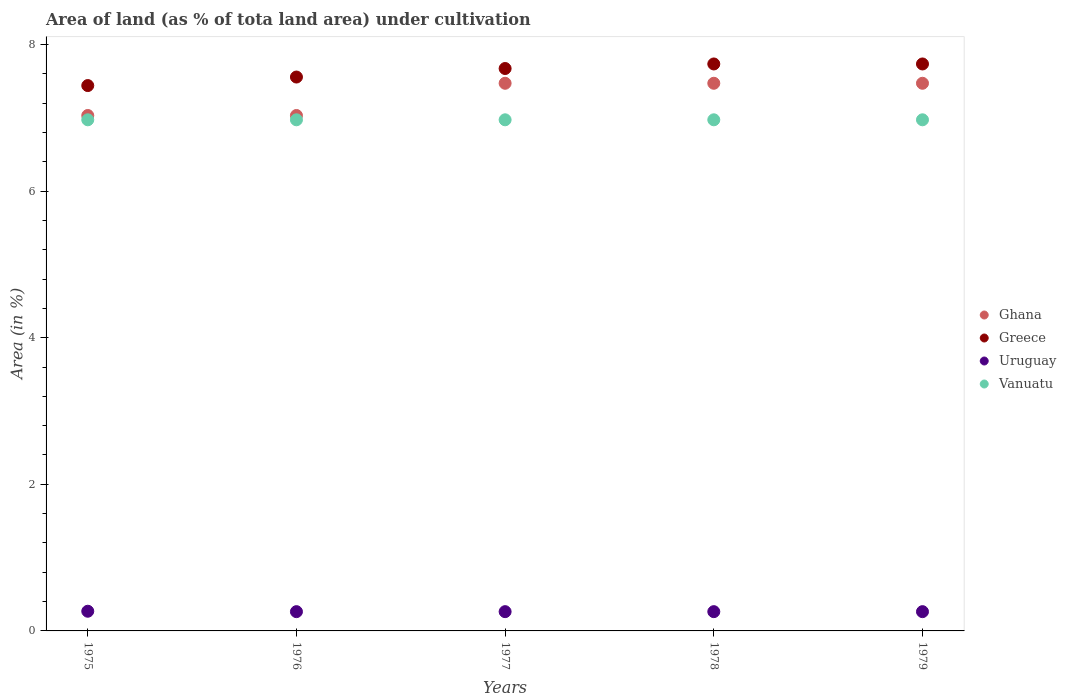What is the percentage of land under cultivation in Ghana in 1976?
Keep it short and to the point. 7.03. Across all years, what is the maximum percentage of land under cultivation in Ghana?
Your answer should be very brief. 7.47. Across all years, what is the minimum percentage of land under cultivation in Greece?
Give a very brief answer. 7.44. In which year was the percentage of land under cultivation in Uruguay maximum?
Provide a short and direct response. 1975. In which year was the percentage of land under cultivation in Ghana minimum?
Keep it short and to the point. 1975. What is the total percentage of land under cultivation in Vanuatu in the graph?
Your answer should be very brief. 34.86. What is the difference between the percentage of land under cultivation in Uruguay in 1978 and that in 1979?
Provide a succinct answer. 0. What is the difference between the percentage of land under cultivation in Greece in 1979 and the percentage of land under cultivation in Uruguay in 1976?
Keep it short and to the point. 7.47. What is the average percentage of land under cultivation in Vanuatu per year?
Provide a short and direct response. 6.97. In the year 1978, what is the difference between the percentage of land under cultivation in Greece and percentage of land under cultivation in Ghana?
Your answer should be compact. 0.26. What is the ratio of the percentage of land under cultivation in Uruguay in 1975 to that in 1977?
Your answer should be very brief. 1.02. Is the percentage of land under cultivation in Vanuatu in 1975 less than that in 1977?
Provide a short and direct response. No. What is the difference between the highest and the second highest percentage of land under cultivation in Uruguay?
Provide a succinct answer. 0.01. Is the sum of the percentage of land under cultivation in Ghana in 1977 and 1979 greater than the maximum percentage of land under cultivation in Uruguay across all years?
Your answer should be compact. Yes. Is it the case that in every year, the sum of the percentage of land under cultivation in Uruguay and percentage of land under cultivation in Ghana  is greater than the percentage of land under cultivation in Greece?
Give a very brief answer. No. How many dotlines are there?
Provide a short and direct response. 4. How many years are there in the graph?
Make the answer very short. 5. What is the title of the graph?
Give a very brief answer. Area of land (as % of tota land area) under cultivation. What is the label or title of the Y-axis?
Offer a very short reply. Area (in %). What is the Area (in %) in Ghana in 1975?
Keep it short and to the point. 7.03. What is the Area (in %) of Greece in 1975?
Keep it short and to the point. 7.44. What is the Area (in %) in Uruguay in 1975?
Give a very brief answer. 0.27. What is the Area (in %) of Vanuatu in 1975?
Give a very brief answer. 6.97. What is the Area (in %) of Ghana in 1976?
Your answer should be compact. 7.03. What is the Area (in %) in Greece in 1976?
Your answer should be very brief. 7.56. What is the Area (in %) of Uruguay in 1976?
Give a very brief answer. 0.26. What is the Area (in %) in Vanuatu in 1976?
Offer a terse response. 6.97. What is the Area (in %) in Ghana in 1977?
Your answer should be compact. 7.47. What is the Area (in %) of Greece in 1977?
Your answer should be compact. 7.67. What is the Area (in %) in Uruguay in 1977?
Make the answer very short. 0.26. What is the Area (in %) in Vanuatu in 1977?
Your response must be concise. 6.97. What is the Area (in %) in Ghana in 1978?
Offer a terse response. 7.47. What is the Area (in %) of Greece in 1978?
Keep it short and to the point. 7.73. What is the Area (in %) of Uruguay in 1978?
Make the answer very short. 0.26. What is the Area (in %) in Vanuatu in 1978?
Your answer should be very brief. 6.97. What is the Area (in %) in Ghana in 1979?
Ensure brevity in your answer.  7.47. What is the Area (in %) of Greece in 1979?
Keep it short and to the point. 7.73. What is the Area (in %) of Uruguay in 1979?
Your answer should be very brief. 0.26. What is the Area (in %) of Vanuatu in 1979?
Provide a short and direct response. 6.97. Across all years, what is the maximum Area (in %) in Ghana?
Your response must be concise. 7.47. Across all years, what is the maximum Area (in %) in Greece?
Provide a succinct answer. 7.73. Across all years, what is the maximum Area (in %) in Uruguay?
Offer a terse response. 0.27. Across all years, what is the maximum Area (in %) in Vanuatu?
Provide a short and direct response. 6.97. Across all years, what is the minimum Area (in %) in Ghana?
Offer a very short reply. 7.03. Across all years, what is the minimum Area (in %) of Greece?
Your answer should be compact. 7.44. Across all years, what is the minimum Area (in %) of Uruguay?
Give a very brief answer. 0.26. Across all years, what is the minimum Area (in %) in Vanuatu?
Ensure brevity in your answer.  6.97. What is the total Area (in %) in Ghana in the graph?
Ensure brevity in your answer.  36.48. What is the total Area (in %) of Greece in the graph?
Make the answer very short. 38.14. What is the total Area (in %) of Uruguay in the graph?
Offer a terse response. 1.32. What is the total Area (in %) in Vanuatu in the graph?
Give a very brief answer. 34.86. What is the difference between the Area (in %) in Ghana in 1975 and that in 1976?
Your answer should be very brief. 0. What is the difference between the Area (in %) in Greece in 1975 and that in 1976?
Offer a terse response. -0.12. What is the difference between the Area (in %) in Uruguay in 1975 and that in 1976?
Your answer should be very brief. 0.01. What is the difference between the Area (in %) in Vanuatu in 1975 and that in 1976?
Your response must be concise. 0. What is the difference between the Area (in %) in Ghana in 1975 and that in 1977?
Your answer should be compact. -0.44. What is the difference between the Area (in %) of Greece in 1975 and that in 1977?
Keep it short and to the point. -0.23. What is the difference between the Area (in %) of Uruguay in 1975 and that in 1977?
Your answer should be very brief. 0.01. What is the difference between the Area (in %) in Ghana in 1975 and that in 1978?
Your response must be concise. -0.44. What is the difference between the Area (in %) in Greece in 1975 and that in 1978?
Provide a short and direct response. -0.29. What is the difference between the Area (in %) in Uruguay in 1975 and that in 1978?
Keep it short and to the point. 0.01. What is the difference between the Area (in %) in Ghana in 1975 and that in 1979?
Make the answer very short. -0.44. What is the difference between the Area (in %) in Greece in 1975 and that in 1979?
Ensure brevity in your answer.  -0.29. What is the difference between the Area (in %) of Uruguay in 1975 and that in 1979?
Provide a short and direct response. 0.01. What is the difference between the Area (in %) in Ghana in 1976 and that in 1977?
Give a very brief answer. -0.44. What is the difference between the Area (in %) in Greece in 1976 and that in 1977?
Ensure brevity in your answer.  -0.12. What is the difference between the Area (in %) in Ghana in 1976 and that in 1978?
Give a very brief answer. -0.44. What is the difference between the Area (in %) in Greece in 1976 and that in 1978?
Your answer should be compact. -0.18. What is the difference between the Area (in %) in Ghana in 1976 and that in 1979?
Offer a terse response. -0.44. What is the difference between the Area (in %) of Greece in 1976 and that in 1979?
Provide a short and direct response. -0.18. What is the difference between the Area (in %) of Uruguay in 1976 and that in 1979?
Ensure brevity in your answer.  0. What is the difference between the Area (in %) of Ghana in 1977 and that in 1978?
Offer a terse response. 0. What is the difference between the Area (in %) of Greece in 1977 and that in 1978?
Offer a very short reply. -0.06. What is the difference between the Area (in %) of Vanuatu in 1977 and that in 1978?
Provide a succinct answer. 0. What is the difference between the Area (in %) in Ghana in 1977 and that in 1979?
Keep it short and to the point. 0. What is the difference between the Area (in %) of Greece in 1977 and that in 1979?
Offer a terse response. -0.06. What is the difference between the Area (in %) in Greece in 1978 and that in 1979?
Offer a very short reply. 0. What is the difference between the Area (in %) of Vanuatu in 1978 and that in 1979?
Provide a succinct answer. 0. What is the difference between the Area (in %) in Ghana in 1975 and the Area (in %) in Greece in 1976?
Your response must be concise. -0.52. What is the difference between the Area (in %) of Ghana in 1975 and the Area (in %) of Uruguay in 1976?
Provide a short and direct response. 6.77. What is the difference between the Area (in %) of Ghana in 1975 and the Area (in %) of Vanuatu in 1976?
Provide a short and direct response. 0.06. What is the difference between the Area (in %) in Greece in 1975 and the Area (in %) in Uruguay in 1976?
Offer a very short reply. 7.18. What is the difference between the Area (in %) in Greece in 1975 and the Area (in %) in Vanuatu in 1976?
Provide a succinct answer. 0.47. What is the difference between the Area (in %) in Uruguay in 1975 and the Area (in %) in Vanuatu in 1976?
Provide a succinct answer. -6.7. What is the difference between the Area (in %) in Ghana in 1975 and the Area (in %) in Greece in 1977?
Provide a short and direct response. -0.64. What is the difference between the Area (in %) of Ghana in 1975 and the Area (in %) of Uruguay in 1977?
Keep it short and to the point. 6.77. What is the difference between the Area (in %) of Ghana in 1975 and the Area (in %) of Vanuatu in 1977?
Offer a terse response. 0.06. What is the difference between the Area (in %) in Greece in 1975 and the Area (in %) in Uruguay in 1977?
Your answer should be very brief. 7.18. What is the difference between the Area (in %) of Greece in 1975 and the Area (in %) of Vanuatu in 1977?
Make the answer very short. 0.47. What is the difference between the Area (in %) in Uruguay in 1975 and the Area (in %) in Vanuatu in 1977?
Make the answer very short. -6.7. What is the difference between the Area (in %) in Ghana in 1975 and the Area (in %) in Greece in 1978?
Your answer should be compact. -0.7. What is the difference between the Area (in %) of Ghana in 1975 and the Area (in %) of Uruguay in 1978?
Your answer should be very brief. 6.77. What is the difference between the Area (in %) in Ghana in 1975 and the Area (in %) in Vanuatu in 1978?
Offer a terse response. 0.06. What is the difference between the Area (in %) in Greece in 1975 and the Area (in %) in Uruguay in 1978?
Provide a succinct answer. 7.18. What is the difference between the Area (in %) of Greece in 1975 and the Area (in %) of Vanuatu in 1978?
Ensure brevity in your answer.  0.47. What is the difference between the Area (in %) of Uruguay in 1975 and the Area (in %) of Vanuatu in 1978?
Keep it short and to the point. -6.7. What is the difference between the Area (in %) in Ghana in 1975 and the Area (in %) in Greece in 1979?
Make the answer very short. -0.7. What is the difference between the Area (in %) of Ghana in 1975 and the Area (in %) of Uruguay in 1979?
Your answer should be compact. 6.77. What is the difference between the Area (in %) in Ghana in 1975 and the Area (in %) in Vanuatu in 1979?
Your answer should be very brief. 0.06. What is the difference between the Area (in %) in Greece in 1975 and the Area (in %) in Uruguay in 1979?
Offer a terse response. 7.18. What is the difference between the Area (in %) in Greece in 1975 and the Area (in %) in Vanuatu in 1979?
Your answer should be compact. 0.47. What is the difference between the Area (in %) of Uruguay in 1975 and the Area (in %) of Vanuatu in 1979?
Your response must be concise. -6.7. What is the difference between the Area (in %) in Ghana in 1976 and the Area (in %) in Greece in 1977?
Offer a terse response. -0.64. What is the difference between the Area (in %) in Ghana in 1976 and the Area (in %) in Uruguay in 1977?
Provide a short and direct response. 6.77. What is the difference between the Area (in %) in Ghana in 1976 and the Area (in %) in Vanuatu in 1977?
Give a very brief answer. 0.06. What is the difference between the Area (in %) in Greece in 1976 and the Area (in %) in Uruguay in 1977?
Your answer should be very brief. 7.29. What is the difference between the Area (in %) of Greece in 1976 and the Area (in %) of Vanuatu in 1977?
Ensure brevity in your answer.  0.58. What is the difference between the Area (in %) in Uruguay in 1976 and the Area (in %) in Vanuatu in 1977?
Give a very brief answer. -6.71. What is the difference between the Area (in %) of Ghana in 1976 and the Area (in %) of Greece in 1978?
Give a very brief answer. -0.7. What is the difference between the Area (in %) of Ghana in 1976 and the Area (in %) of Uruguay in 1978?
Make the answer very short. 6.77. What is the difference between the Area (in %) of Ghana in 1976 and the Area (in %) of Vanuatu in 1978?
Ensure brevity in your answer.  0.06. What is the difference between the Area (in %) of Greece in 1976 and the Area (in %) of Uruguay in 1978?
Provide a succinct answer. 7.29. What is the difference between the Area (in %) of Greece in 1976 and the Area (in %) of Vanuatu in 1978?
Your answer should be very brief. 0.58. What is the difference between the Area (in %) of Uruguay in 1976 and the Area (in %) of Vanuatu in 1978?
Offer a very short reply. -6.71. What is the difference between the Area (in %) in Ghana in 1976 and the Area (in %) in Greece in 1979?
Ensure brevity in your answer.  -0.7. What is the difference between the Area (in %) of Ghana in 1976 and the Area (in %) of Uruguay in 1979?
Make the answer very short. 6.77. What is the difference between the Area (in %) in Ghana in 1976 and the Area (in %) in Vanuatu in 1979?
Offer a very short reply. 0.06. What is the difference between the Area (in %) of Greece in 1976 and the Area (in %) of Uruguay in 1979?
Offer a very short reply. 7.29. What is the difference between the Area (in %) of Greece in 1976 and the Area (in %) of Vanuatu in 1979?
Your answer should be compact. 0.58. What is the difference between the Area (in %) in Uruguay in 1976 and the Area (in %) in Vanuatu in 1979?
Make the answer very short. -6.71. What is the difference between the Area (in %) in Ghana in 1977 and the Area (in %) in Greece in 1978?
Provide a succinct answer. -0.26. What is the difference between the Area (in %) of Ghana in 1977 and the Area (in %) of Uruguay in 1978?
Provide a short and direct response. 7.21. What is the difference between the Area (in %) in Ghana in 1977 and the Area (in %) in Vanuatu in 1978?
Make the answer very short. 0.5. What is the difference between the Area (in %) in Greece in 1977 and the Area (in %) in Uruguay in 1978?
Ensure brevity in your answer.  7.41. What is the difference between the Area (in %) in Greece in 1977 and the Area (in %) in Vanuatu in 1978?
Make the answer very short. 0.7. What is the difference between the Area (in %) of Uruguay in 1977 and the Area (in %) of Vanuatu in 1978?
Make the answer very short. -6.71. What is the difference between the Area (in %) in Ghana in 1977 and the Area (in %) in Greece in 1979?
Give a very brief answer. -0.26. What is the difference between the Area (in %) of Ghana in 1977 and the Area (in %) of Uruguay in 1979?
Your answer should be compact. 7.21. What is the difference between the Area (in %) of Ghana in 1977 and the Area (in %) of Vanuatu in 1979?
Keep it short and to the point. 0.5. What is the difference between the Area (in %) of Greece in 1977 and the Area (in %) of Uruguay in 1979?
Your response must be concise. 7.41. What is the difference between the Area (in %) in Greece in 1977 and the Area (in %) in Vanuatu in 1979?
Your answer should be very brief. 0.7. What is the difference between the Area (in %) in Uruguay in 1977 and the Area (in %) in Vanuatu in 1979?
Make the answer very short. -6.71. What is the difference between the Area (in %) of Ghana in 1978 and the Area (in %) of Greece in 1979?
Keep it short and to the point. -0.26. What is the difference between the Area (in %) of Ghana in 1978 and the Area (in %) of Uruguay in 1979?
Ensure brevity in your answer.  7.21. What is the difference between the Area (in %) in Ghana in 1978 and the Area (in %) in Vanuatu in 1979?
Offer a very short reply. 0.5. What is the difference between the Area (in %) in Greece in 1978 and the Area (in %) in Uruguay in 1979?
Provide a succinct answer. 7.47. What is the difference between the Area (in %) in Greece in 1978 and the Area (in %) in Vanuatu in 1979?
Provide a short and direct response. 0.76. What is the difference between the Area (in %) in Uruguay in 1978 and the Area (in %) in Vanuatu in 1979?
Ensure brevity in your answer.  -6.71. What is the average Area (in %) of Ghana per year?
Offer a very short reply. 7.3. What is the average Area (in %) in Greece per year?
Provide a short and direct response. 7.63. What is the average Area (in %) of Uruguay per year?
Give a very brief answer. 0.26. What is the average Area (in %) in Vanuatu per year?
Offer a very short reply. 6.97. In the year 1975, what is the difference between the Area (in %) in Ghana and Area (in %) in Greece?
Your answer should be compact. -0.41. In the year 1975, what is the difference between the Area (in %) in Ghana and Area (in %) in Uruguay?
Your response must be concise. 6.76. In the year 1975, what is the difference between the Area (in %) of Ghana and Area (in %) of Vanuatu?
Offer a terse response. 0.06. In the year 1975, what is the difference between the Area (in %) in Greece and Area (in %) in Uruguay?
Ensure brevity in your answer.  7.17. In the year 1975, what is the difference between the Area (in %) of Greece and Area (in %) of Vanuatu?
Make the answer very short. 0.47. In the year 1975, what is the difference between the Area (in %) in Uruguay and Area (in %) in Vanuatu?
Your answer should be compact. -6.7. In the year 1976, what is the difference between the Area (in %) of Ghana and Area (in %) of Greece?
Give a very brief answer. -0.52. In the year 1976, what is the difference between the Area (in %) of Ghana and Area (in %) of Uruguay?
Your answer should be very brief. 6.77. In the year 1976, what is the difference between the Area (in %) of Ghana and Area (in %) of Vanuatu?
Offer a very short reply. 0.06. In the year 1976, what is the difference between the Area (in %) of Greece and Area (in %) of Uruguay?
Your answer should be compact. 7.29. In the year 1976, what is the difference between the Area (in %) of Greece and Area (in %) of Vanuatu?
Provide a short and direct response. 0.58. In the year 1976, what is the difference between the Area (in %) of Uruguay and Area (in %) of Vanuatu?
Keep it short and to the point. -6.71. In the year 1977, what is the difference between the Area (in %) in Ghana and Area (in %) in Greece?
Your answer should be very brief. -0.2. In the year 1977, what is the difference between the Area (in %) in Ghana and Area (in %) in Uruguay?
Ensure brevity in your answer.  7.21. In the year 1977, what is the difference between the Area (in %) in Ghana and Area (in %) in Vanuatu?
Your answer should be very brief. 0.5. In the year 1977, what is the difference between the Area (in %) of Greece and Area (in %) of Uruguay?
Provide a short and direct response. 7.41. In the year 1977, what is the difference between the Area (in %) in Greece and Area (in %) in Vanuatu?
Keep it short and to the point. 0.7. In the year 1977, what is the difference between the Area (in %) of Uruguay and Area (in %) of Vanuatu?
Your response must be concise. -6.71. In the year 1978, what is the difference between the Area (in %) of Ghana and Area (in %) of Greece?
Offer a terse response. -0.26. In the year 1978, what is the difference between the Area (in %) of Ghana and Area (in %) of Uruguay?
Your answer should be very brief. 7.21. In the year 1978, what is the difference between the Area (in %) of Ghana and Area (in %) of Vanuatu?
Your answer should be very brief. 0.5. In the year 1978, what is the difference between the Area (in %) in Greece and Area (in %) in Uruguay?
Provide a short and direct response. 7.47. In the year 1978, what is the difference between the Area (in %) of Greece and Area (in %) of Vanuatu?
Your answer should be compact. 0.76. In the year 1978, what is the difference between the Area (in %) in Uruguay and Area (in %) in Vanuatu?
Your answer should be very brief. -6.71. In the year 1979, what is the difference between the Area (in %) of Ghana and Area (in %) of Greece?
Your response must be concise. -0.26. In the year 1979, what is the difference between the Area (in %) in Ghana and Area (in %) in Uruguay?
Ensure brevity in your answer.  7.21. In the year 1979, what is the difference between the Area (in %) in Ghana and Area (in %) in Vanuatu?
Offer a very short reply. 0.5. In the year 1979, what is the difference between the Area (in %) of Greece and Area (in %) of Uruguay?
Give a very brief answer. 7.47. In the year 1979, what is the difference between the Area (in %) of Greece and Area (in %) of Vanuatu?
Your answer should be compact. 0.76. In the year 1979, what is the difference between the Area (in %) in Uruguay and Area (in %) in Vanuatu?
Provide a succinct answer. -6.71. What is the ratio of the Area (in %) of Ghana in 1975 to that in 1976?
Offer a very short reply. 1. What is the ratio of the Area (in %) in Greece in 1975 to that in 1976?
Offer a very short reply. 0.98. What is the ratio of the Area (in %) in Uruguay in 1975 to that in 1976?
Your answer should be very brief. 1.02. What is the ratio of the Area (in %) in Ghana in 1975 to that in 1977?
Keep it short and to the point. 0.94. What is the ratio of the Area (in %) in Greece in 1975 to that in 1977?
Your response must be concise. 0.97. What is the ratio of the Area (in %) in Uruguay in 1975 to that in 1977?
Provide a short and direct response. 1.02. What is the ratio of the Area (in %) in Greece in 1975 to that in 1978?
Ensure brevity in your answer.  0.96. What is the ratio of the Area (in %) of Uruguay in 1975 to that in 1978?
Your answer should be very brief. 1.02. What is the ratio of the Area (in %) of Vanuatu in 1975 to that in 1978?
Offer a very short reply. 1. What is the ratio of the Area (in %) in Ghana in 1975 to that in 1979?
Your response must be concise. 0.94. What is the ratio of the Area (in %) of Greece in 1975 to that in 1979?
Provide a succinct answer. 0.96. What is the ratio of the Area (in %) of Uruguay in 1975 to that in 1979?
Provide a short and direct response. 1.02. What is the ratio of the Area (in %) of Vanuatu in 1975 to that in 1979?
Your answer should be compact. 1. What is the ratio of the Area (in %) in Greece in 1976 to that in 1978?
Your answer should be compact. 0.98. What is the ratio of the Area (in %) in Vanuatu in 1976 to that in 1978?
Your answer should be compact. 1. What is the ratio of the Area (in %) of Ghana in 1976 to that in 1979?
Your answer should be very brief. 0.94. What is the ratio of the Area (in %) in Greece in 1976 to that in 1979?
Your answer should be very brief. 0.98. What is the ratio of the Area (in %) of Uruguay in 1976 to that in 1979?
Your answer should be compact. 1. What is the ratio of the Area (in %) of Ghana in 1977 to that in 1978?
Your answer should be very brief. 1. What is the ratio of the Area (in %) in Greece in 1977 to that in 1978?
Your response must be concise. 0.99. What is the ratio of the Area (in %) of Vanuatu in 1977 to that in 1978?
Your answer should be compact. 1. What is the ratio of the Area (in %) in Ghana in 1977 to that in 1979?
Offer a very short reply. 1. What is the ratio of the Area (in %) in Uruguay in 1977 to that in 1979?
Make the answer very short. 1. What is the ratio of the Area (in %) in Ghana in 1978 to that in 1979?
Offer a terse response. 1. What is the ratio of the Area (in %) of Greece in 1978 to that in 1979?
Ensure brevity in your answer.  1. What is the difference between the highest and the second highest Area (in %) in Ghana?
Make the answer very short. 0. What is the difference between the highest and the second highest Area (in %) in Uruguay?
Your response must be concise. 0.01. What is the difference between the highest and the lowest Area (in %) in Ghana?
Keep it short and to the point. 0.44. What is the difference between the highest and the lowest Area (in %) of Greece?
Ensure brevity in your answer.  0.29. What is the difference between the highest and the lowest Area (in %) in Uruguay?
Your response must be concise. 0.01. What is the difference between the highest and the lowest Area (in %) of Vanuatu?
Offer a terse response. 0. 